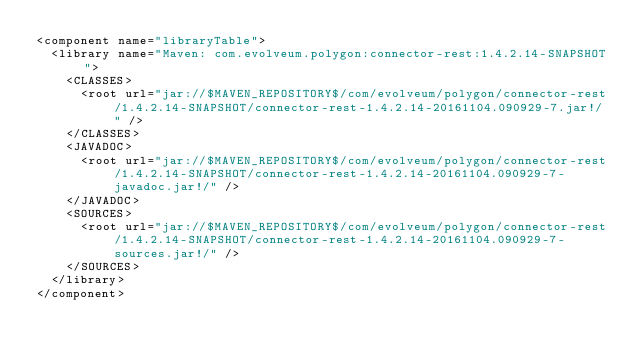Convert code to text. <code><loc_0><loc_0><loc_500><loc_500><_XML_><component name="libraryTable">
  <library name="Maven: com.evolveum.polygon:connector-rest:1.4.2.14-SNAPSHOT">
    <CLASSES>
      <root url="jar://$MAVEN_REPOSITORY$/com/evolveum/polygon/connector-rest/1.4.2.14-SNAPSHOT/connector-rest-1.4.2.14-20161104.090929-7.jar!/" />
    </CLASSES>
    <JAVADOC>
      <root url="jar://$MAVEN_REPOSITORY$/com/evolveum/polygon/connector-rest/1.4.2.14-SNAPSHOT/connector-rest-1.4.2.14-20161104.090929-7-javadoc.jar!/" />
    </JAVADOC>
    <SOURCES>
      <root url="jar://$MAVEN_REPOSITORY$/com/evolveum/polygon/connector-rest/1.4.2.14-SNAPSHOT/connector-rest-1.4.2.14-20161104.090929-7-sources.jar!/" />
    </SOURCES>
  </library>
</component></code> 